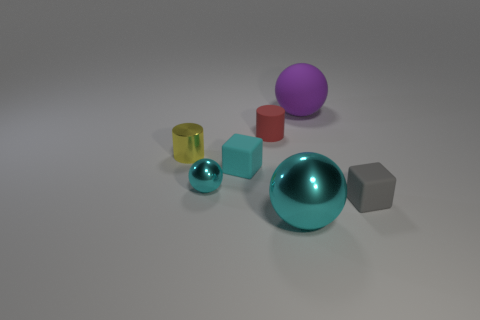Are there any other things of the same color as the small shiny cylinder?
Keep it short and to the point. No. What number of big purple matte objects are in front of the metallic ball behind the tiny cube on the right side of the big cyan shiny object?
Provide a short and direct response. 0. What number of matte things are there?
Keep it short and to the point. 4. Are there fewer tiny cyan matte objects that are left of the small cyan ball than small cyan spheres that are right of the large metal ball?
Provide a succinct answer. No. Is the number of tiny cyan matte things in front of the tiny metallic sphere less than the number of big gray rubber cylinders?
Your answer should be compact. No. What material is the object in front of the small rubber cube that is to the right of the large thing on the left side of the purple object made of?
Give a very brief answer. Metal. What number of things are either small cubes that are behind the tiny metallic ball or cyan objects to the right of the tiny cyan metal thing?
Your response must be concise. 2. What material is the other large object that is the same shape as the big purple thing?
Offer a very short reply. Metal. What number of rubber things are large things or gray objects?
Give a very brief answer. 2. There is a cyan object that is the same material as the tiny gray cube; what is its shape?
Keep it short and to the point. Cube. 